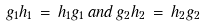Convert formula to latex. <formula><loc_0><loc_0><loc_500><loc_500>g _ { 1 } h _ { 1 } \, = \, h _ { 1 } g _ { 1 } \, a n d \, g _ { 2 } h _ { 2 } \, = \, h _ { 2 } g _ { 2 }</formula> 